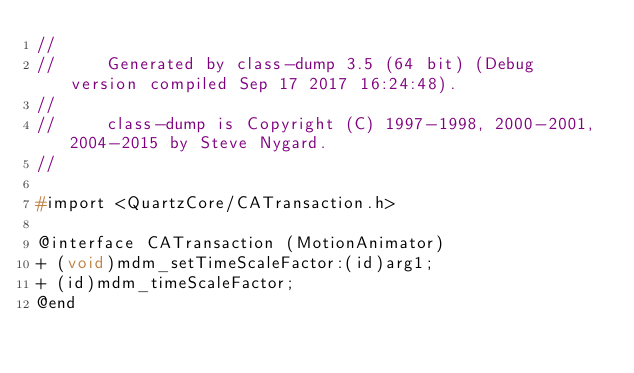Convert code to text. <code><loc_0><loc_0><loc_500><loc_500><_C_>//
//     Generated by class-dump 3.5 (64 bit) (Debug version compiled Sep 17 2017 16:24:48).
//
//     class-dump is Copyright (C) 1997-1998, 2000-2001, 2004-2015 by Steve Nygard.
//

#import <QuartzCore/CATransaction.h>

@interface CATransaction (MotionAnimator)
+ (void)mdm_setTimeScaleFactor:(id)arg1;
+ (id)mdm_timeScaleFactor;
@end

</code> 